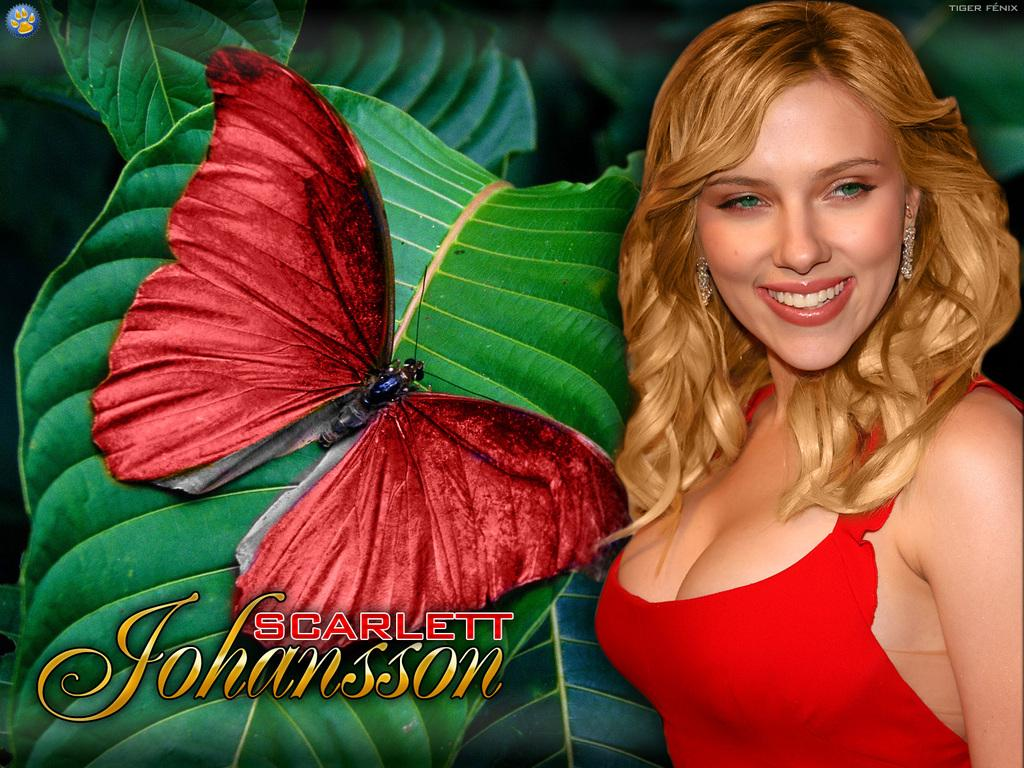Who is the main subject in the image? There is a woman in the image. Where is the woman located in the image? The woman is on the right side of the image. What is the woman wearing? The woman is wearing a red dress. What other living creature can be seen in the image? There is a butterfly in the image. Where is the butterfly located in the image? The butterfly is on a leaf. What rhythm is the clock playing in the image? There is no clock present in the image, so it cannot be determined if any rhythm is being played. 